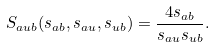<formula> <loc_0><loc_0><loc_500><loc_500>S _ { a u b } ( s _ { a b } , s _ { a u } , s _ { u b } ) = \frac { 4 s _ { a b } } { s _ { a u } s _ { u b } } .</formula> 